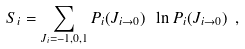<formula> <loc_0><loc_0><loc_500><loc_500>S _ { i } = \sum _ { J _ { i } = - 1 , 0 , 1 } P _ { i } ( J _ { i \to 0 } ) \ \ln P _ { i } ( J _ { i \to 0 } ) \ ,</formula> 